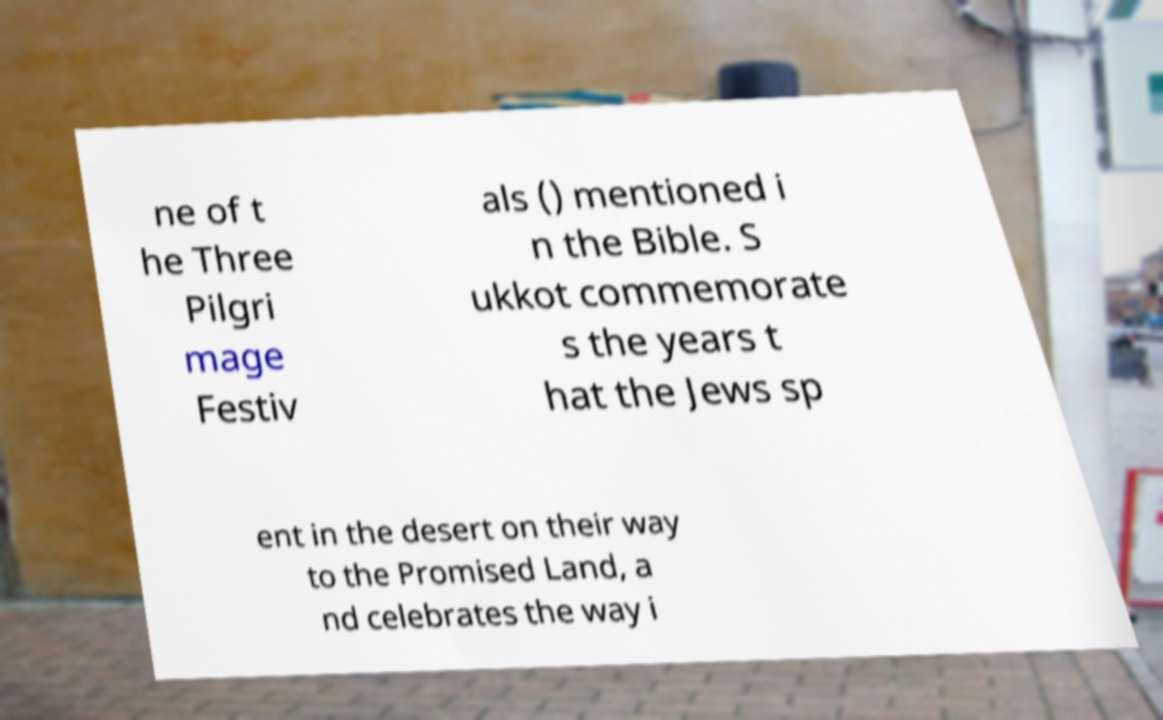Please identify and transcribe the text found in this image. ne of t he Three Pilgri mage Festiv als () mentioned i n the Bible. S ukkot commemorate s the years t hat the Jews sp ent in the desert on their way to the Promised Land, a nd celebrates the way i 